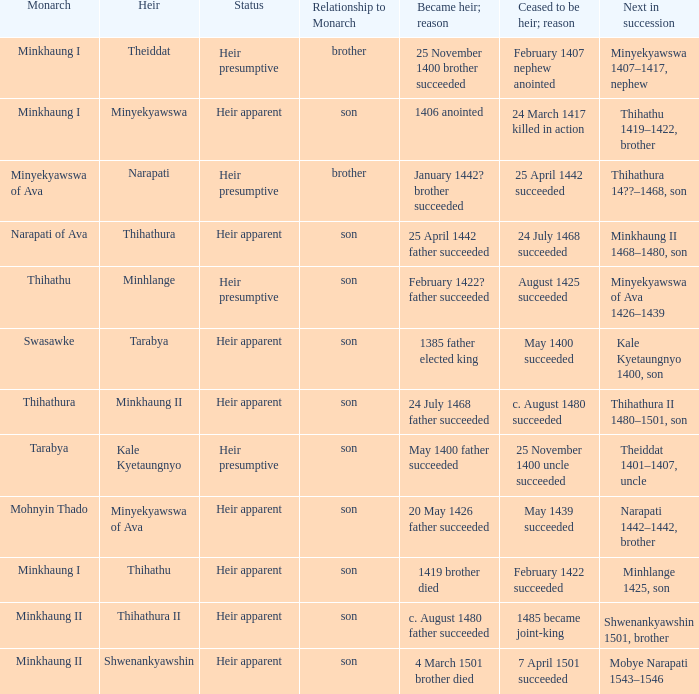What was the relationship to monarch of the heir Minyekyawswa? Son. 